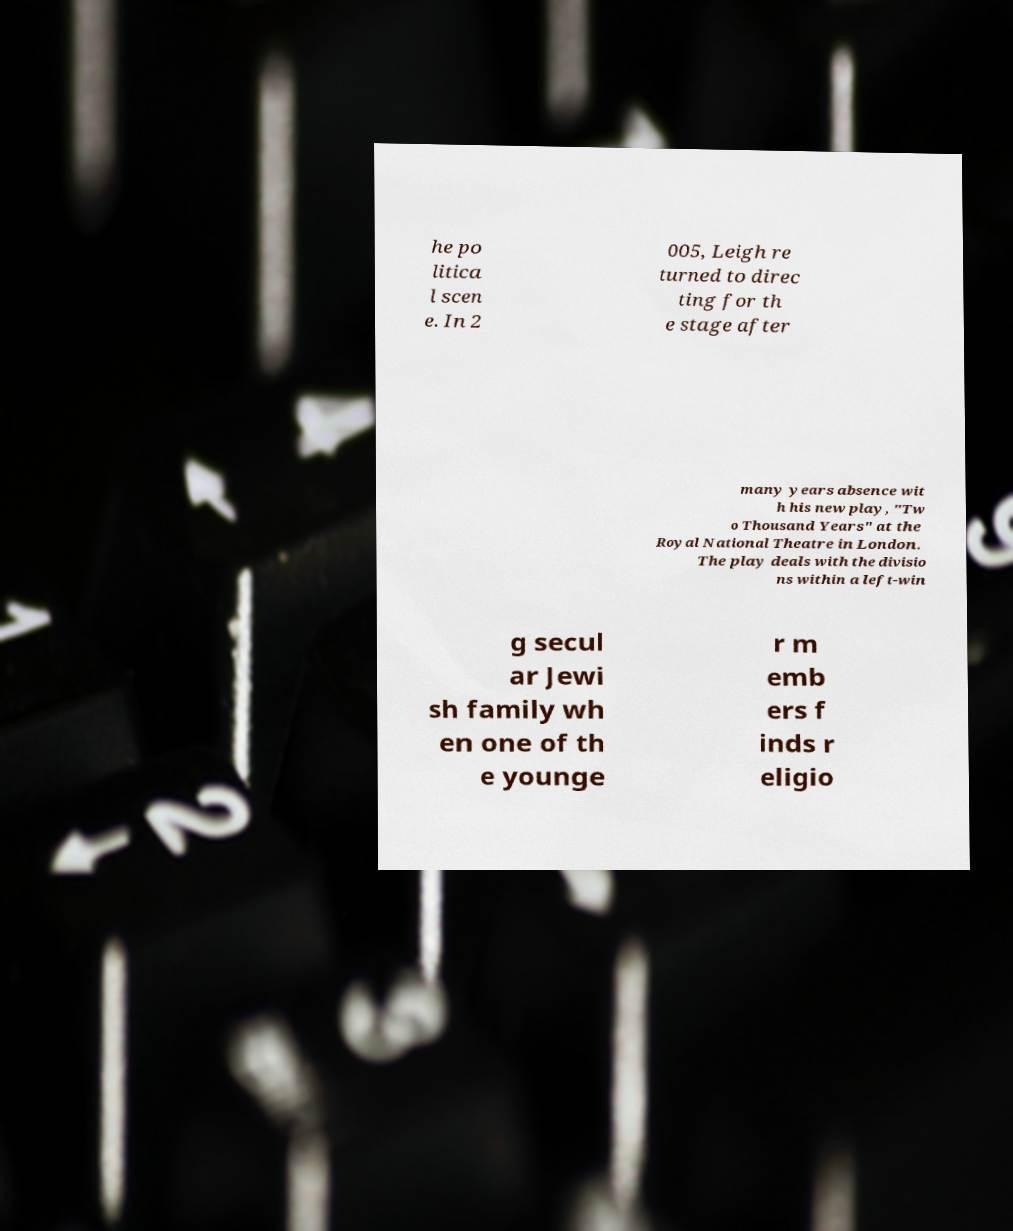Could you assist in decoding the text presented in this image and type it out clearly? he po litica l scen e. In 2 005, Leigh re turned to direc ting for th e stage after many years absence wit h his new play, "Tw o Thousand Years" at the Royal National Theatre in London. The play deals with the divisio ns within a left-win g secul ar Jewi sh family wh en one of th e younge r m emb ers f inds r eligio 